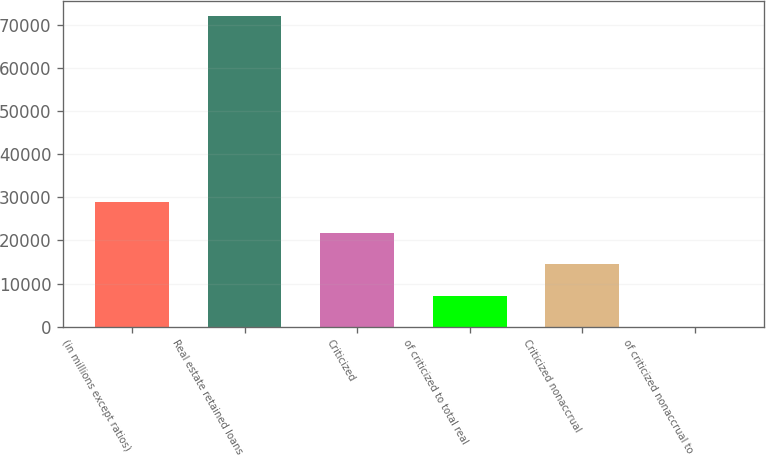Convert chart. <chart><loc_0><loc_0><loc_500><loc_500><bar_chart><fcel>(in millions except ratios)<fcel>Real estate retained loans<fcel>Criticized<fcel>of criticized to total real<fcel>Criticized nonaccrual<fcel>of criticized nonaccrual to<nl><fcel>28857.2<fcel>72143<fcel>21643<fcel>7214.37<fcel>14428.7<fcel>0.08<nl></chart> 